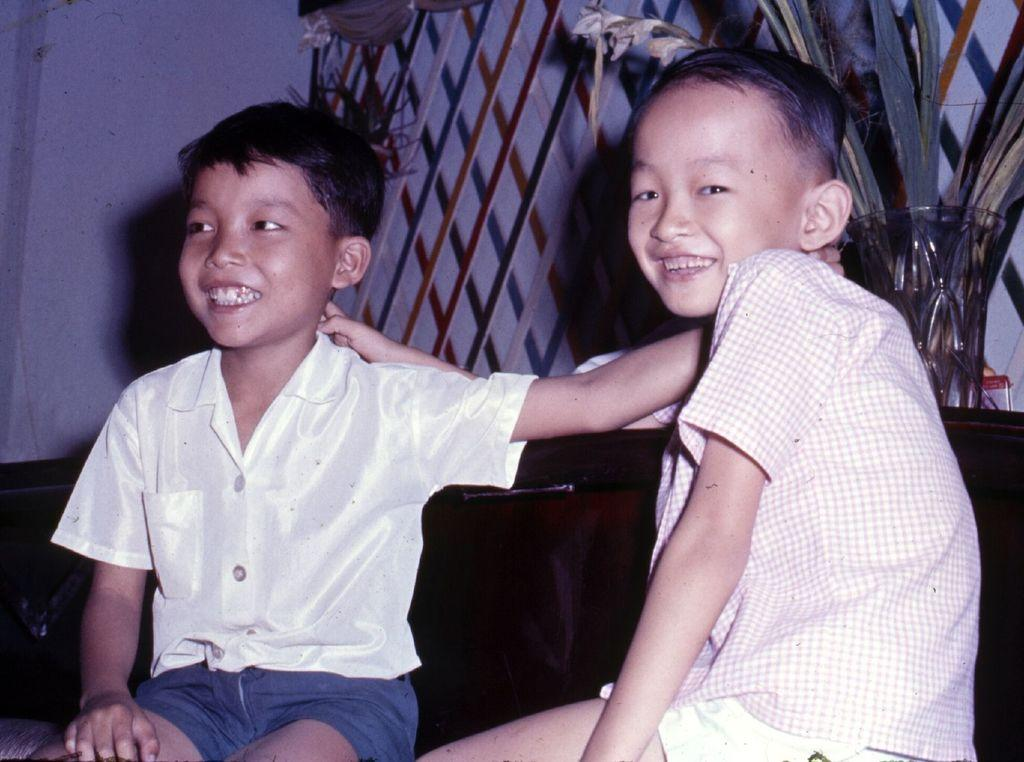How many children are present in the image? There are two kids in the image. What is the gender of the children? The kids are boys. Can you describe any objects or elements in the background or on the side of the image? Yes, there is a flower vase on the right side of the image. What type of zinc object can be seen in the image? There is no zinc object present in the image. Are the boys in the image kissing each other? The image does not show the boys kissing; they are simply standing together. 